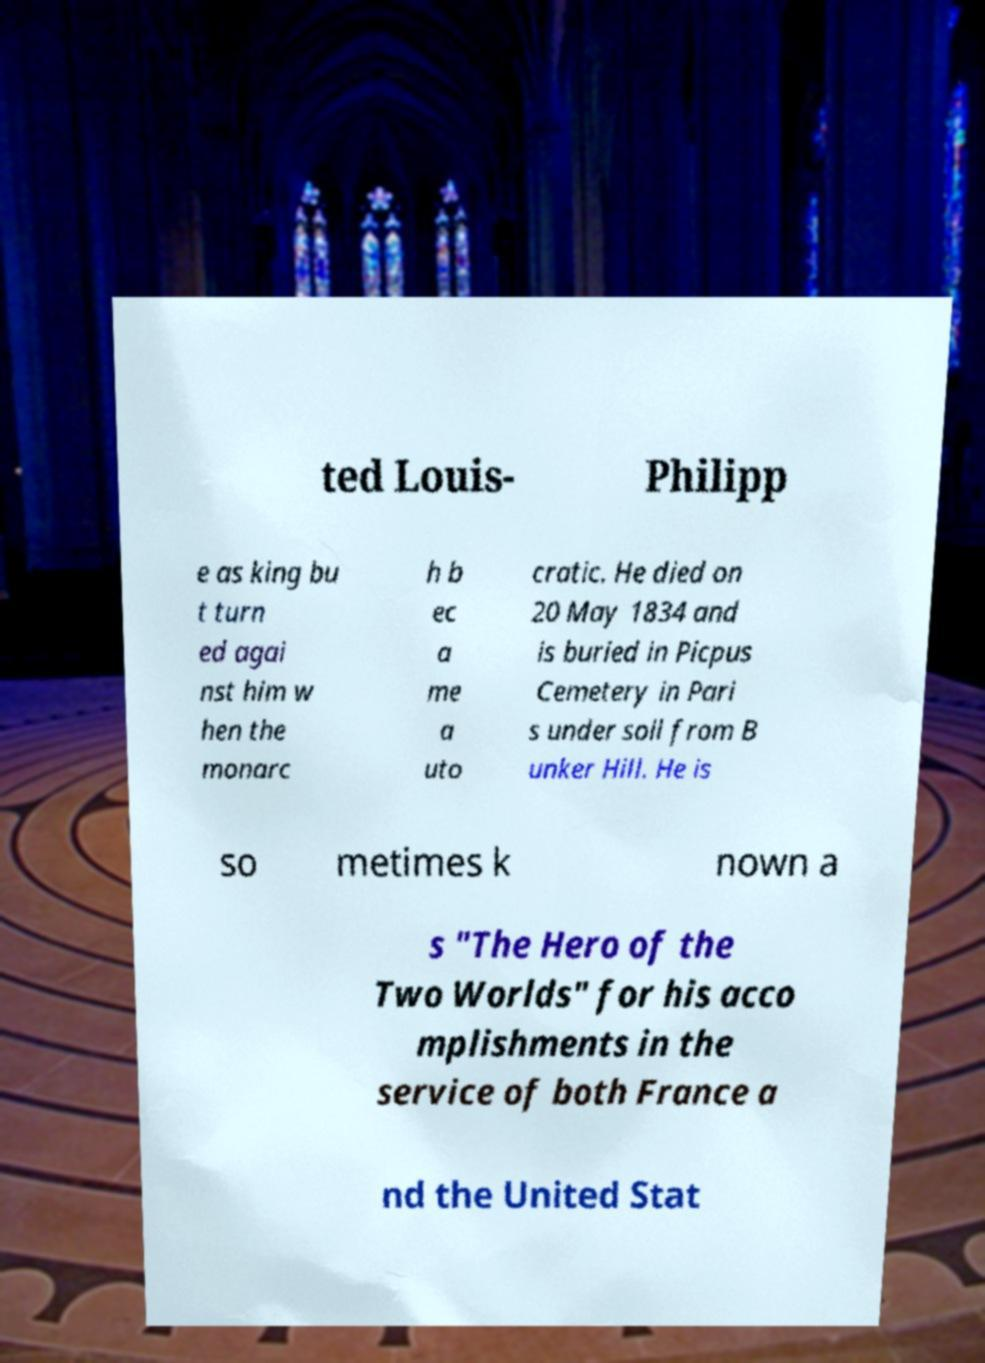Can you accurately transcribe the text from the provided image for me? ted Louis- Philipp e as king bu t turn ed agai nst him w hen the monarc h b ec a me a uto cratic. He died on 20 May 1834 and is buried in Picpus Cemetery in Pari s under soil from B unker Hill. He is so metimes k nown a s "The Hero of the Two Worlds" for his acco mplishments in the service of both France a nd the United Stat 